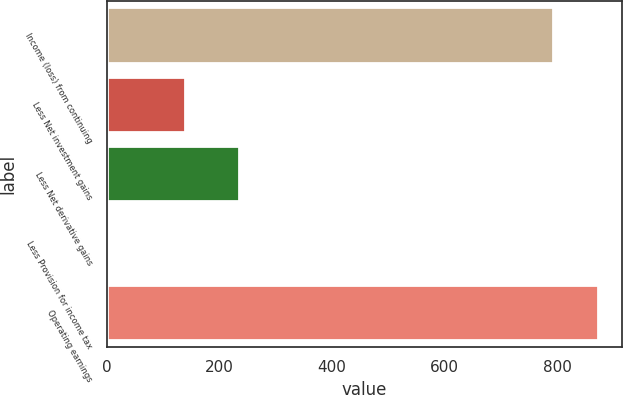Convert chart to OTSL. <chart><loc_0><loc_0><loc_500><loc_500><bar_chart><fcel>Income (loss) from continuing<fcel>Less Net investment gains<fcel>Less Net derivative gains<fcel>Less Provision for income tax<fcel>Operating earnings<nl><fcel>792<fcel>139<fcel>235<fcel>4<fcel>871.9<nl></chart> 